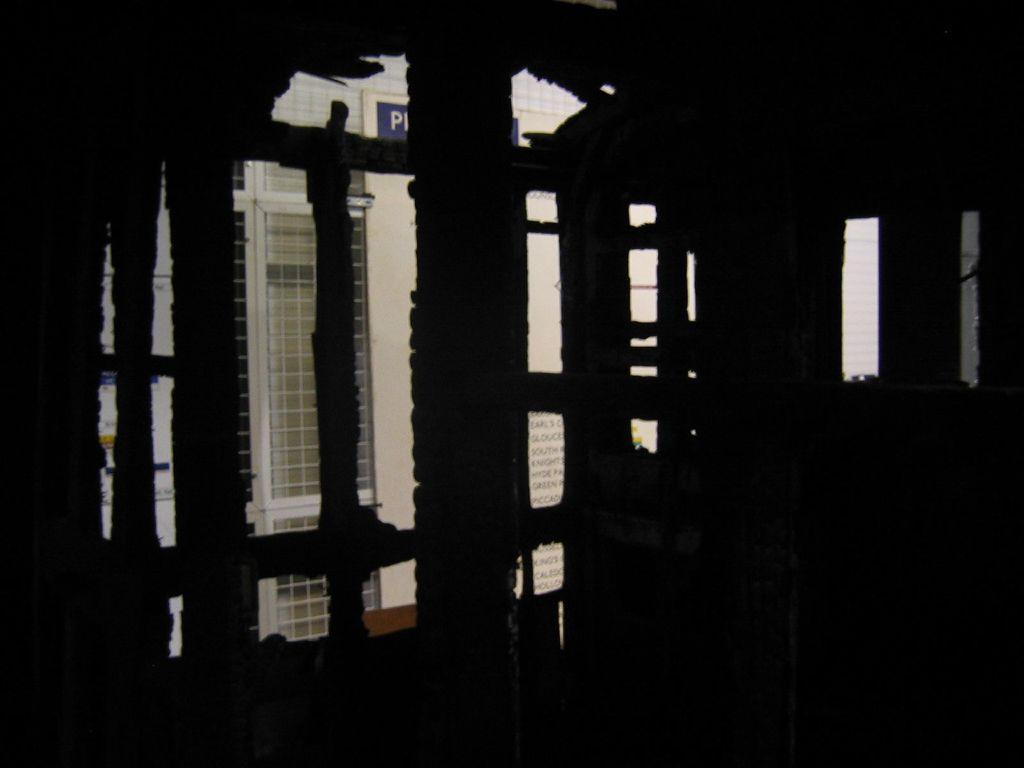What is the location from where the image is taken? The image is taken from inside a building. How is the image taken from inside the building? The image is taken through a window. What can be seen outside the building in the image? The outside of the building is visible in the image. What type of dinner is being served in the park after the aftermath of the event? There is no dinner, park, or event mentioned or visible in the image. 